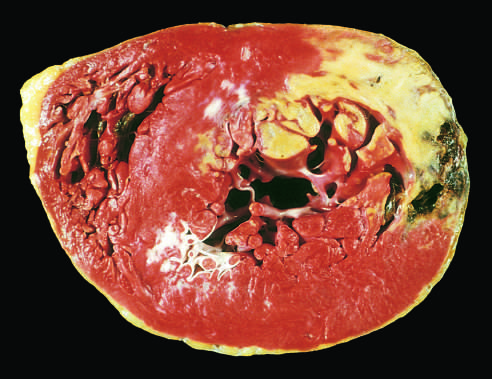when is the absence of staining due to enzyme leakage?
Answer the question using a single word or phrase. After cell death 